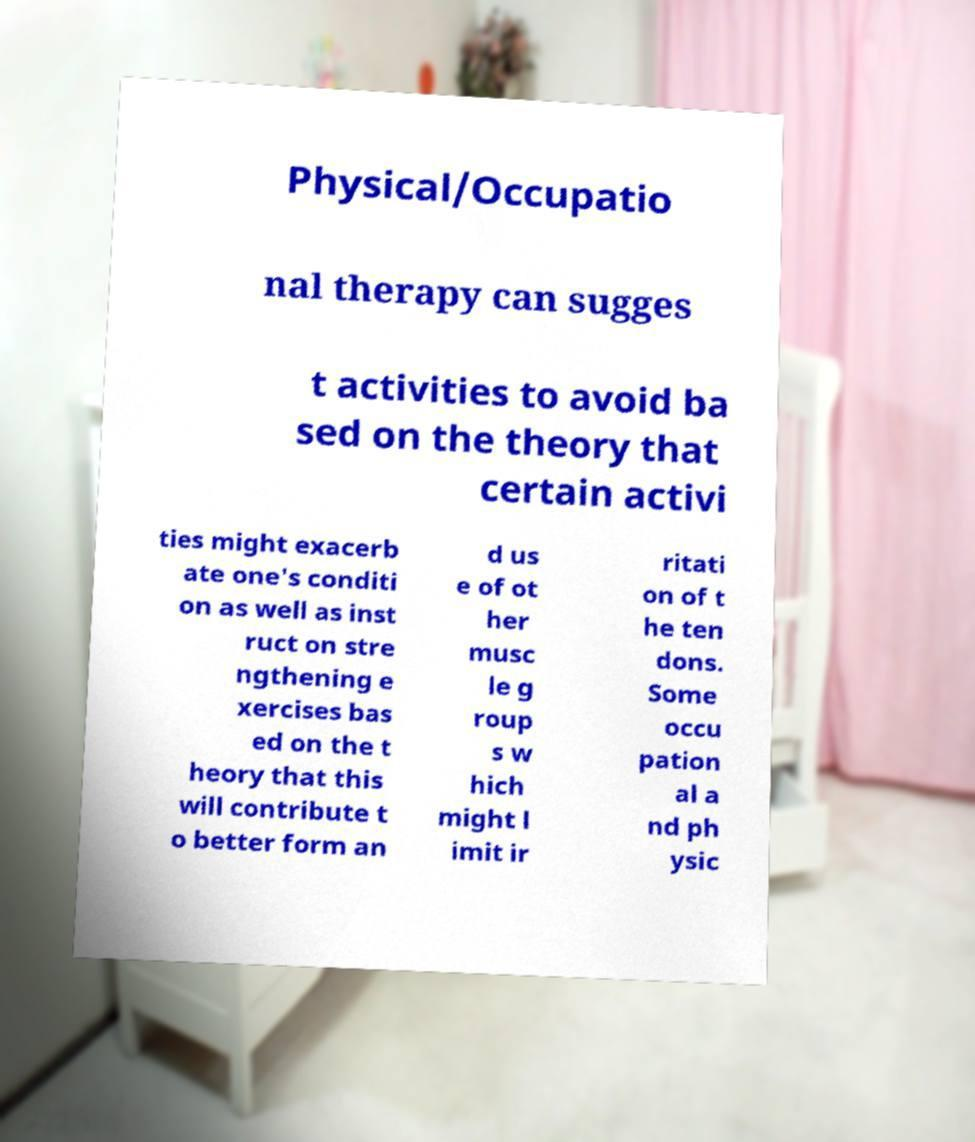I need the written content from this picture converted into text. Can you do that? Physical/Occupatio nal therapy can sugges t activities to avoid ba sed on the theory that certain activi ties might exacerb ate one's conditi on as well as inst ruct on stre ngthening e xercises bas ed on the t heory that this will contribute t o better form an d us e of ot her musc le g roup s w hich might l imit ir ritati on of t he ten dons. Some occu pation al a nd ph ysic 